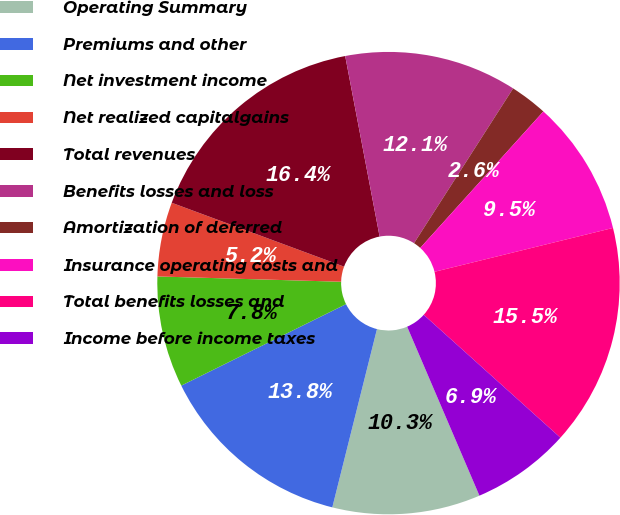<chart> <loc_0><loc_0><loc_500><loc_500><pie_chart><fcel>Operating Summary<fcel>Premiums and other<fcel>Net investment income<fcel>Net realized capitalgains<fcel>Total revenues<fcel>Benefits losses and loss<fcel>Amortization of deferred<fcel>Insurance operating costs and<fcel>Total benefits losses and<fcel>Income before income taxes<nl><fcel>10.34%<fcel>13.78%<fcel>7.77%<fcel>5.19%<fcel>16.35%<fcel>12.06%<fcel>2.62%<fcel>9.48%<fcel>15.49%<fcel>6.91%<nl></chart> 